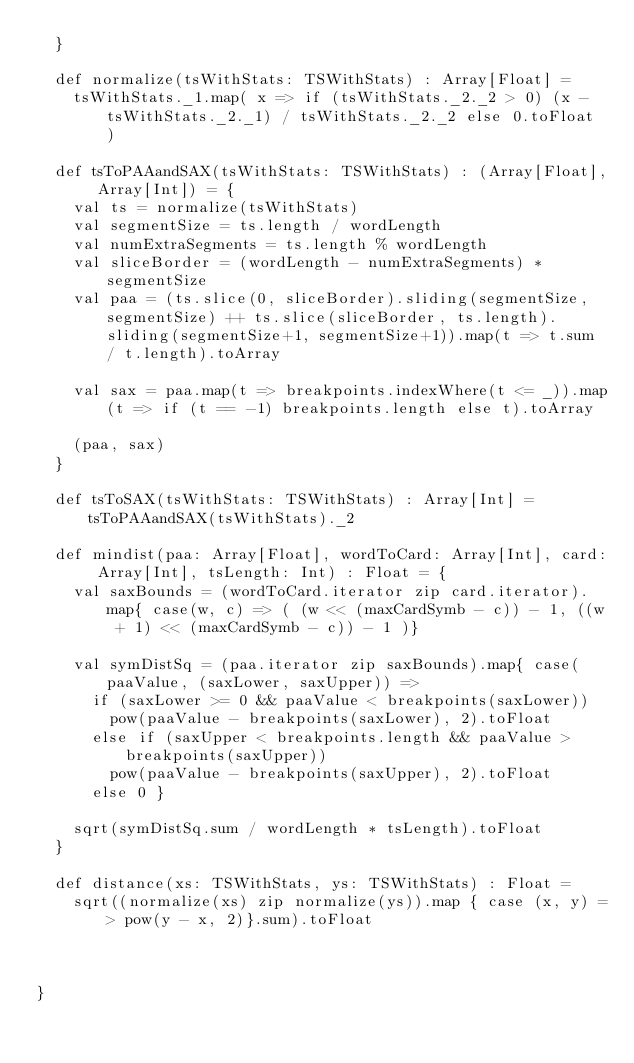Convert code to text. <code><loc_0><loc_0><loc_500><loc_500><_Scala_>  }

  def normalize(tsWithStats: TSWithStats) : Array[Float] =
    tsWithStats._1.map( x => if (tsWithStats._2._2 > 0) (x - tsWithStats._2._1) / tsWithStats._2._2 else 0.toFloat )

  def tsToPAAandSAX(tsWithStats: TSWithStats) : (Array[Float], Array[Int]) = {
    val ts = normalize(tsWithStats)
    val segmentSize = ts.length / wordLength
    val numExtraSegments = ts.length % wordLength
    val sliceBorder = (wordLength - numExtraSegments) * segmentSize
    val paa = (ts.slice(0, sliceBorder).sliding(segmentSize, segmentSize) ++ ts.slice(sliceBorder, ts.length).sliding(segmentSize+1, segmentSize+1)).map(t => t.sum / t.length).toArray

    val sax = paa.map(t => breakpoints.indexWhere(t <= _)).map(t => if (t == -1) breakpoints.length else t).toArray

    (paa, sax)
  }

  def tsToSAX(tsWithStats: TSWithStats) : Array[Int] = tsToPAAandSAX(tsWithStats)._2

  def mindist(paa: Array[Float], wordToCard: Array[Int], card: Array[Int], tsLength: Int) : Float = {
    val saxBounds = (wordToCard.iterator zip card.iterator).map{ case(w, c) => ( (w << (maxCardSymb - c)) - 1, ((w + 1) << (maxCardSymb - c)) - 1 )}

    val symDistSq = (paa.iterator zip saxBounds).map{ case(paaValue, (saxLower, saxUpper)) =>
      if (saxLower >= 0 && paaValue < breakpoints(saxLower))
        pow(paaValue - breakpoints(saxLower), 2).toFloat
      else if (saxUpper < breakpoints.length && paaValue > breakpoints(saxUpper))
        pow(paaValue - breakpoints(saxUpper), 2).toFloat
      else 0 }

    sqrt(symDistSq.sum / wordLength * tsLength).toFloat
  }

  def distance(xs: TSWithStats, ys: TSWithStats) : Float =
    sqrt((normalize(xs) zip normalize(ys)).map { case (x, y) => pow(y - x, 2)}.sum).toFloat



}
</code> 